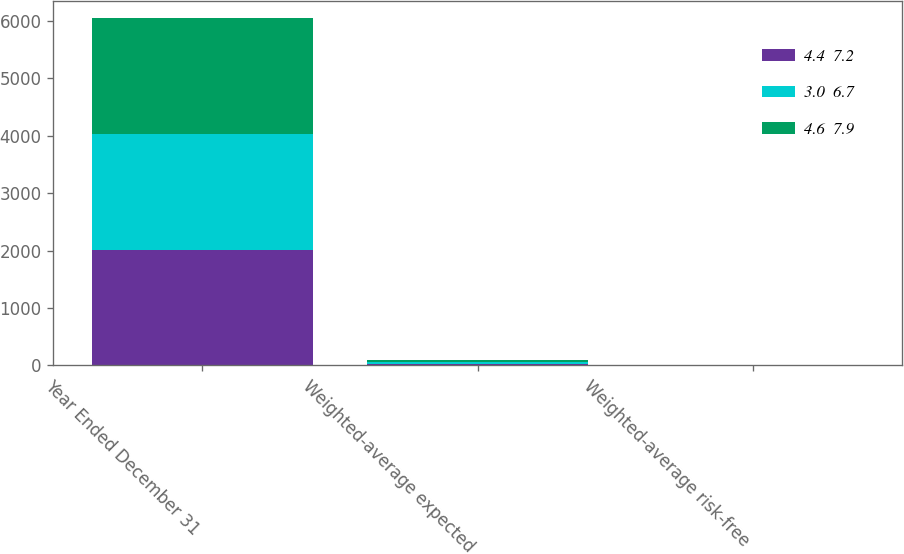Convert chart to OTSL. <chart><loc_0><loc_0><loc_500><loc_500><stacked_bar_chart><ecel><fcel>Year Ended December 31<fcel>Weighted-average expected<fcel>Weighted-average risk-free<nl><fcel>4.4  7.2<fcel>2014<fcel>28<fcel>2.4<nl><fcel>3.0  6.7<fcel>2013<fcel>28<fcel>2.5<nl><fcel>4.6  7.9<fcel>2012<fcel>31<fcel>1.8<nl></chart> 